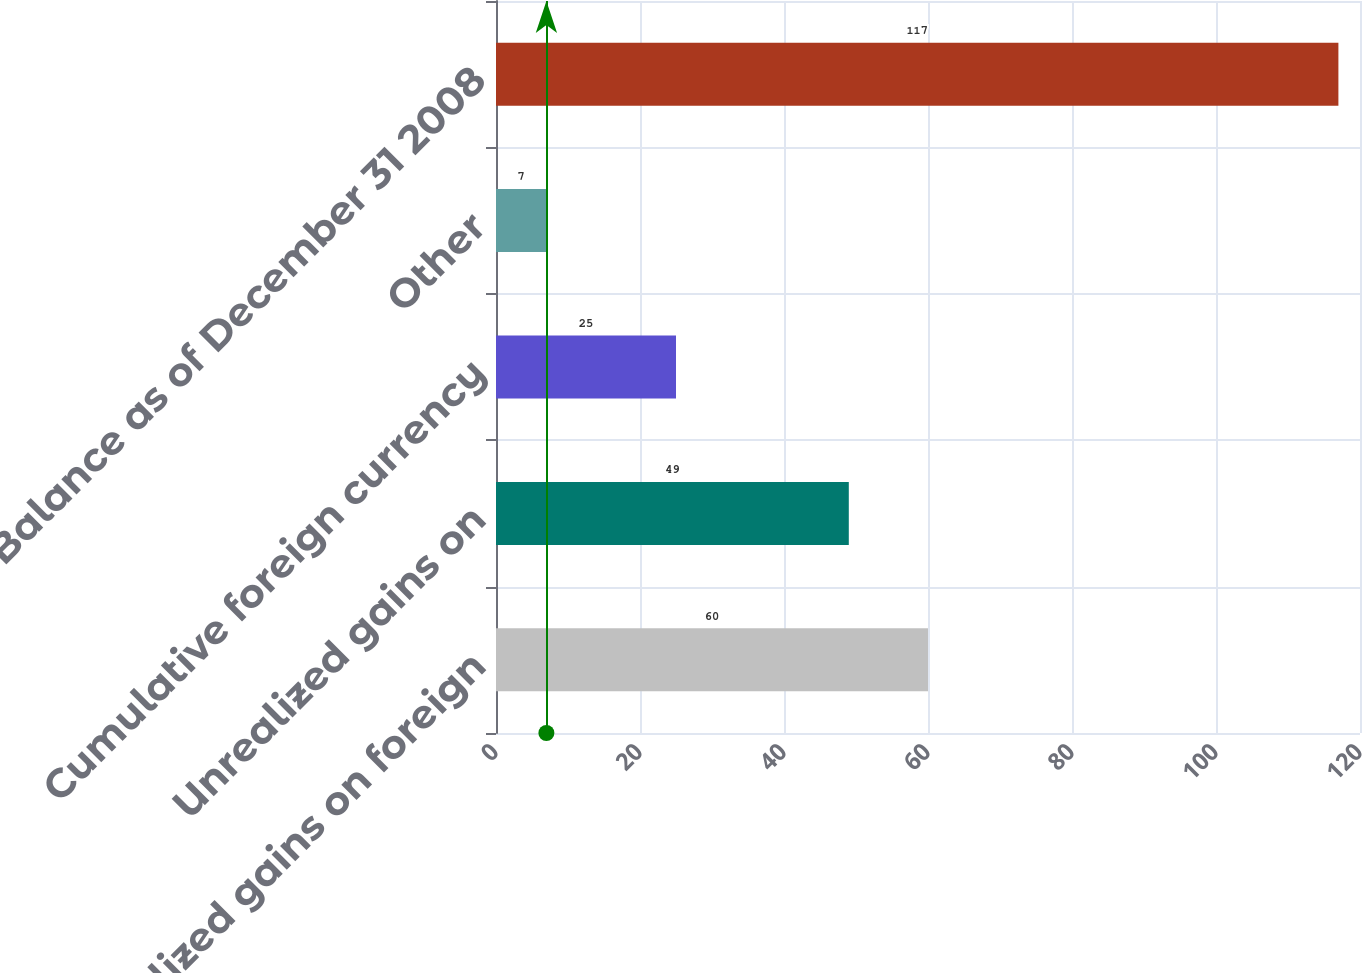Convert chart to OTSL. <chart><loc_0><loc_0><loc_500><loc_500><bar_chart><fcel>Unrealized gains on foreign<fcel>Unrealized gains on<fcel>Cumulative foreign currency<fcel>Other<fcel>Balance as of December 31 2008<nl><fcel>60<fcel>49<fcel>25<fcel>7<fcel>117<nl></chart> 